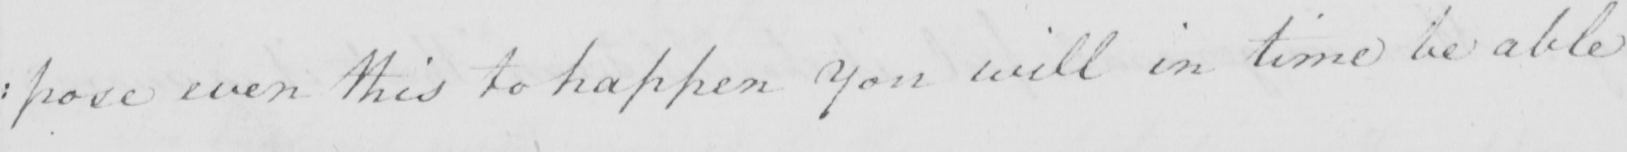What does this handwritten line say? : pose even this to happen You will in time be able 